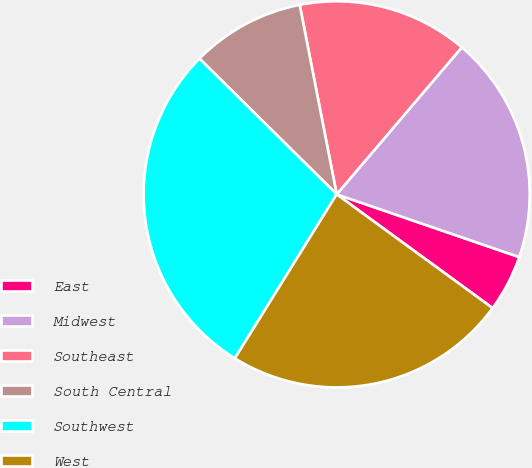Convert chart to OTSL. <chart><loc_0><loc_0><loc_500><loc_500><pie_chart><fcel>East<fcel>Midwest<fcel>Southeast<fcel>South Central<fcel>Southwest<fcel>West<nl><fcel>4.76%<fcel>19.05%<fcel>14.29%<fcel>9.52%<fcel>28.57%<fcel>23.81%<nl></chart> 